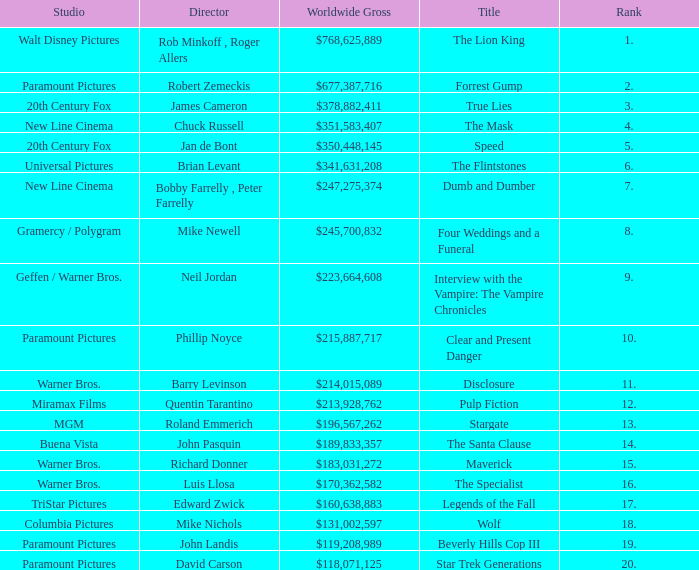What is the Rank of the Film with a Worldwide Gross of $183,031,272? 15.0. 